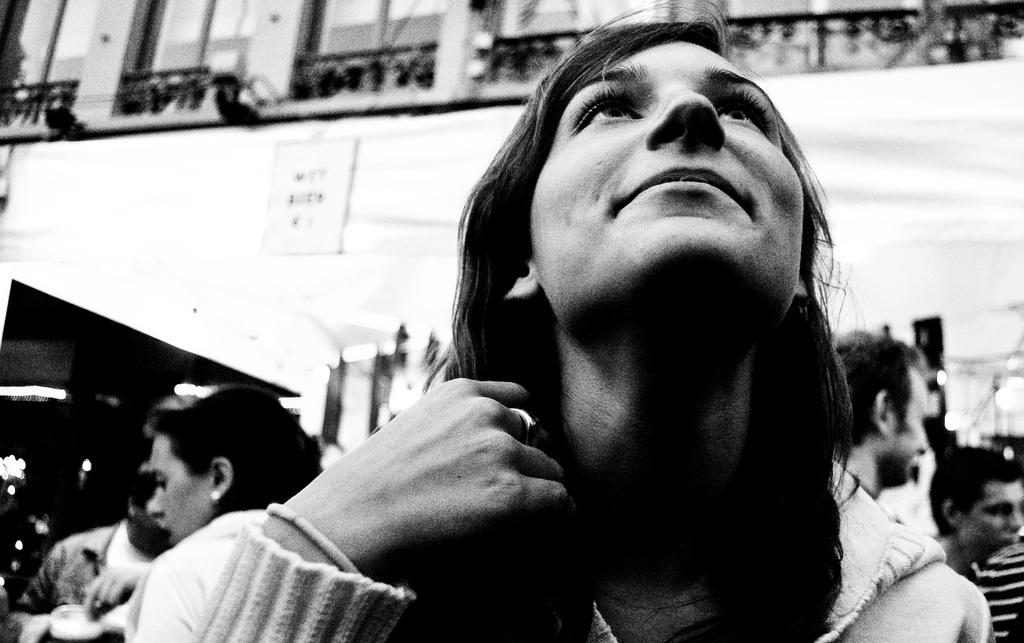Who is the main subject in the image? There is a woman in the image. Where is the woman positioned in the image? The woman is on the front of the image. What is the woman doing in the image? The woman is looking up. What type of knife is the woman holding in the image? There is no knife present in the image; the woman is simply looking up. 